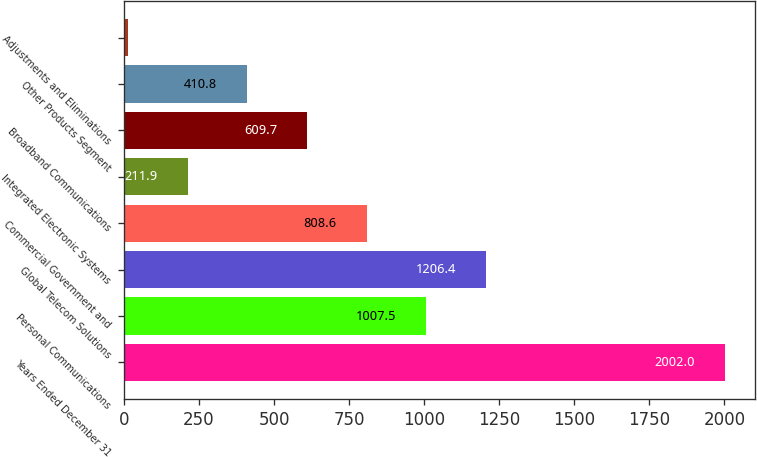<chart> <loc_0><loc_0><loc_500><loc_500><bar_chart><fcel>Years Ended December 31<fcel>Personal Communications<fcel>Global Telecom Solutions<fcel>Commercial Government and<fcel>Integrated Electronic Systems<fcel>Broadband Communications<fcel>Other Products Segment<fcel>Adjustments and Eliminations<nl><fcel>2002<fcel>1007.5<fcel>1206.4<fcel>808.6<fcel>211.9<fcel>609.7<fcel>410.8<fcel>13<nl></chart> 